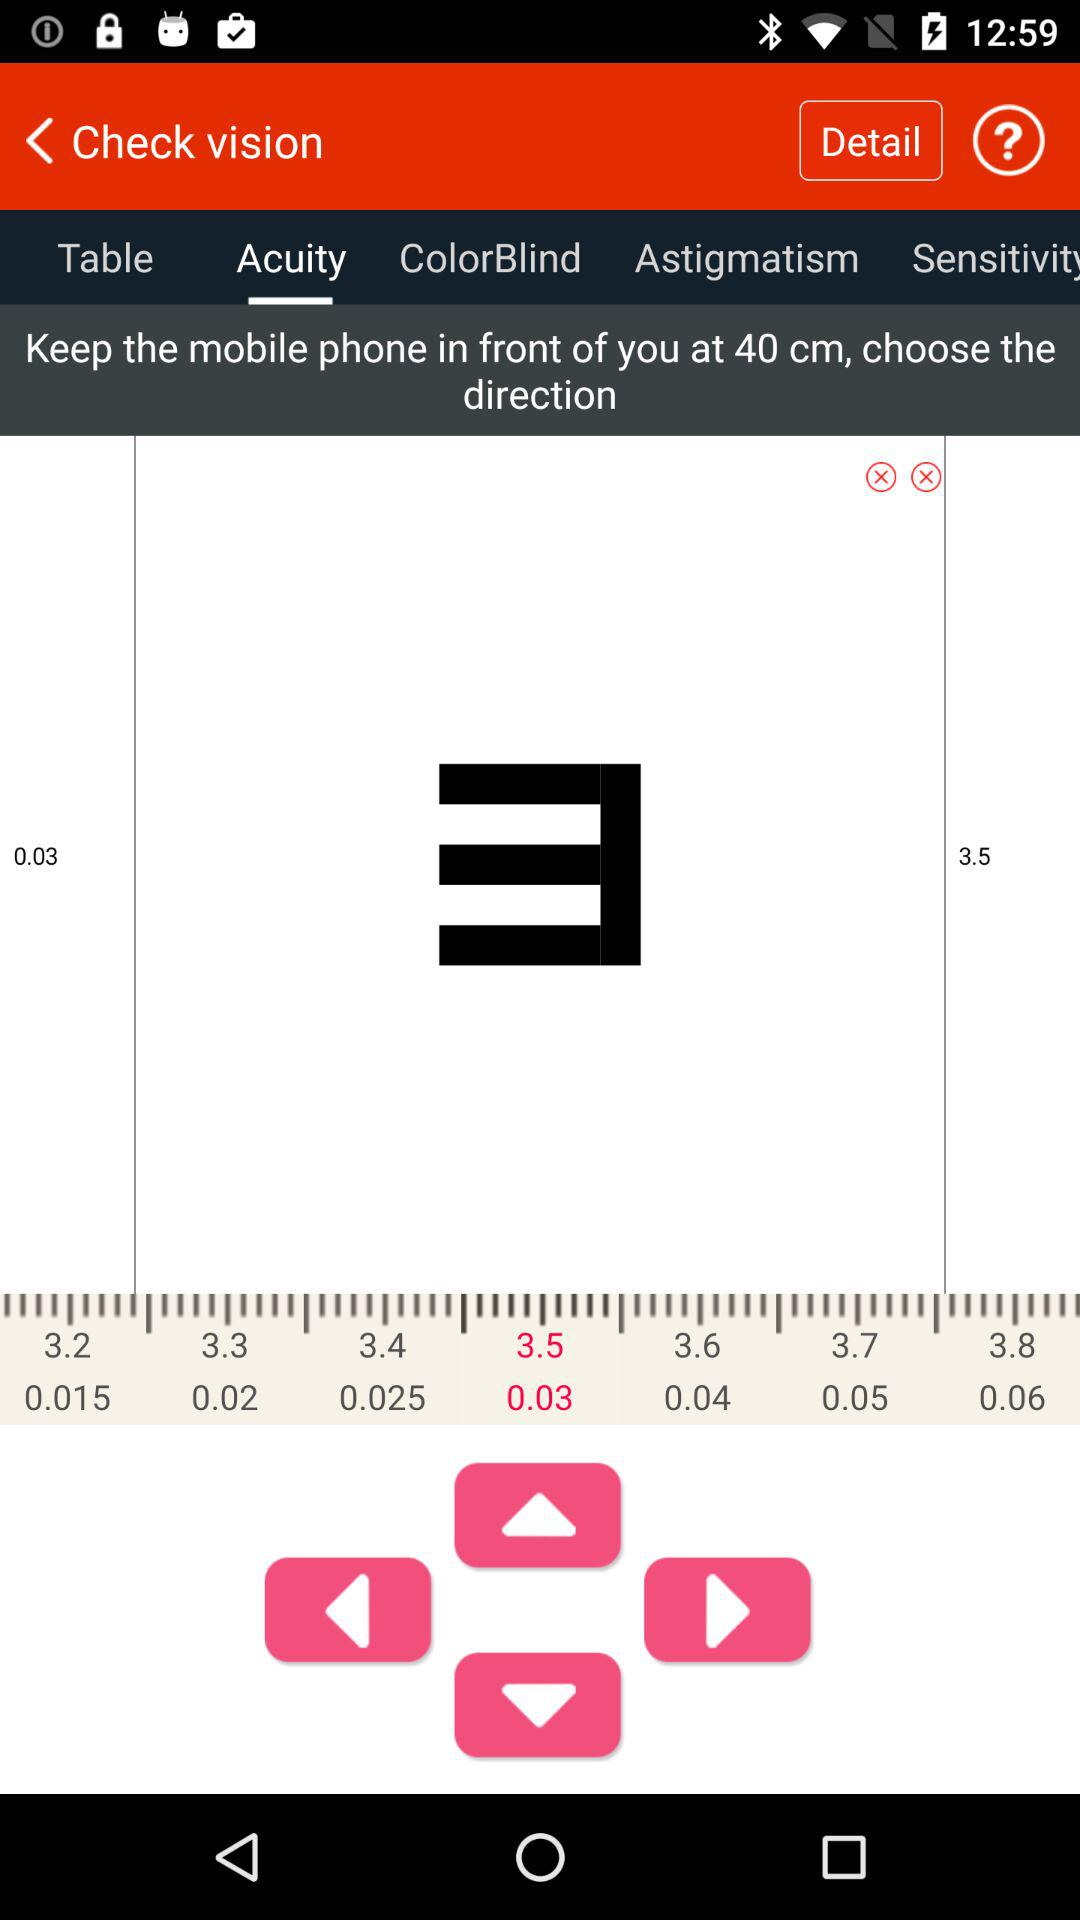What is the app name?
When the provided information is insufficient, respond with <no answer>. <no answer> 